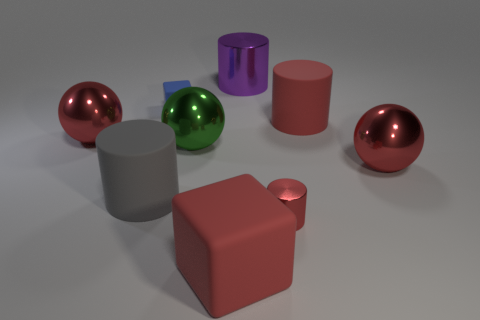There is a red cylinder behind the red shiny cylinder; how many big gray cylinders are in front of it?
Make the answer very short. 1. There is a gray thing that is the same shape as the large purple shiny object; what is its material?
Make the answer very short. Rubber. The tiny matte block is what color?
Keep it short and to the point. Blue. What number of things are either tiny red cylinders or cyan cylinders?
Your answer should be compact. 1. There is a gray object to the right of the large red shiny ball that is left of the blue rubber block; what is its shape?
Your response must be concise. Cylinder. How many other things are there of the same material as the large gray cylinder?
Make the answer very short. 3. Do the tiny cube and the tiny red cylinder that is in front of the large green thing have the same material?
Give a very brief answer. No. How many things are large metal spheres that are to the right of the gray matte cylinder or objects that are left of the green metallic object?
Provide a succinct answer. 5. What number of other objects are the same color as the tiny matte cube?
Offer a terse response. 0. Are there more large red matte cylinders behind the blue rubber block than small blue blocks that are in front of the large metal cylinder?
Keep it short and to the point. No. 